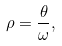Convert formula to latex. <formula><loc_0><loc_0><loc_500><loc_500>\rho = \frac { \theta } { \omega } ,</formula> 